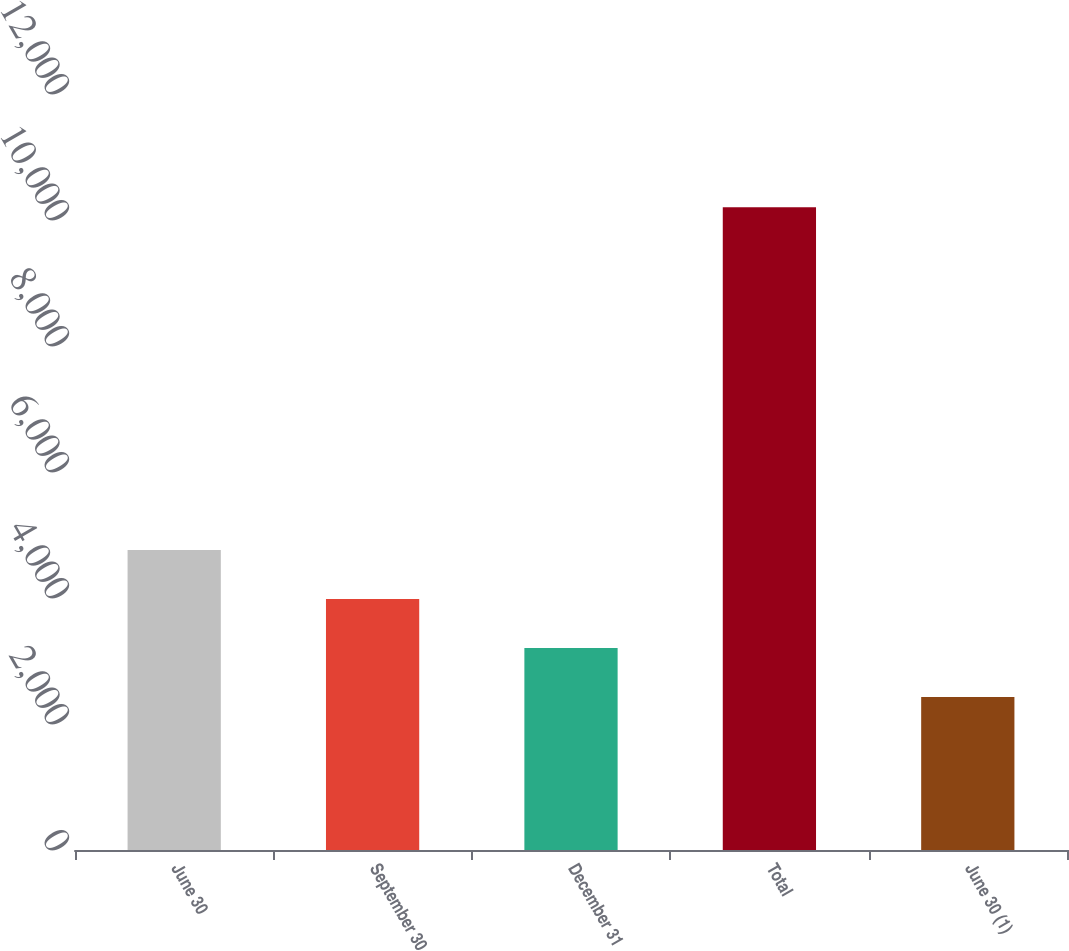Convert chart to OTSL. <chart><loc_0><loc_0><loc_500><loc_500><bar_chart><fcel>June 30<fcel>September 30<fcel>December 31<fcel>Total<fcel>June 30 (1)<nl><fcel>4760.6<fcel>3983.4<fcel>3206.2<fcel>10201<fcel>2429<nl></chart> 